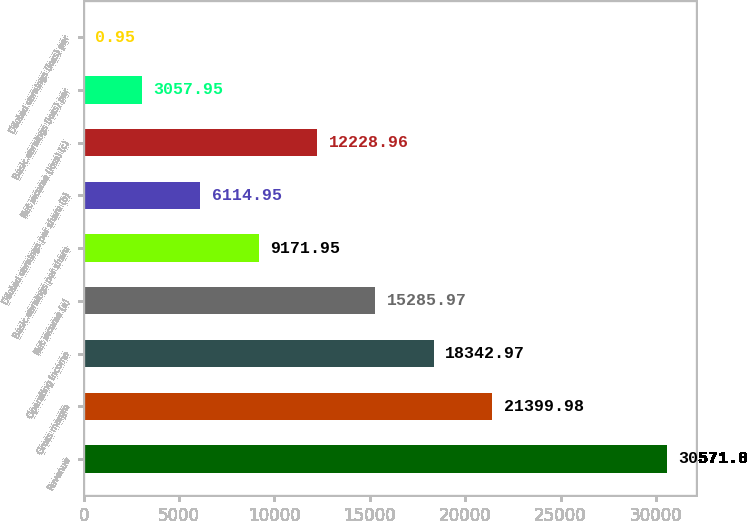Convert chart. <chart><loc_0><loc_0><loc_500><loc_500><bar_chart><fcel>Revenue<fcel>Gross margin<fcel>Operating income<fcel>Net income (a)<fcel>Basic earnings per share<fcel>Diluted earnings per share (b)<fcel>Net income (loss) (c)<fcel>Basic earnings (loss) per<fcel>Diluted earnings (loss) per<nl><fcel>30571<fcel>21400<fcel>18343<fcel>15286<fcel>9171.95<fcel>6114.95<fcel>12229<fcel>3057.95<fcel>0.95<nl></chart> 